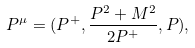Convert formula to latex. <formula><loc_0><loc_0><loc_500><loc_500>P ^ { \mu } = ( P ^ { + } , \frac { P ^ { 2 } + M ^ { 2 } } { 2 P ^ { + } } , P ) ,</formula> 